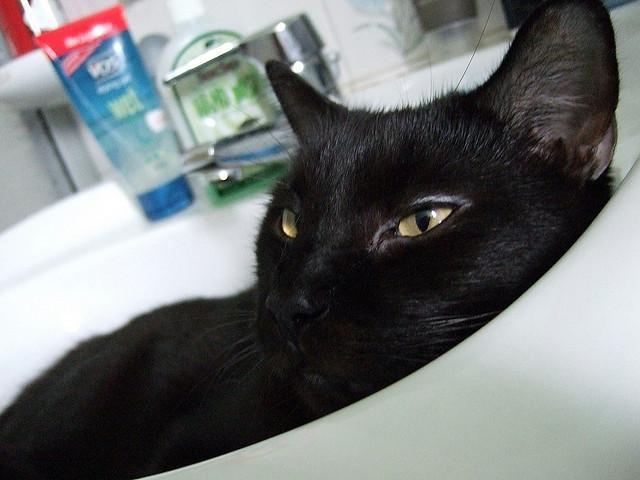How many handles does the refrigerator have?
Give a very brief answer. 0. 